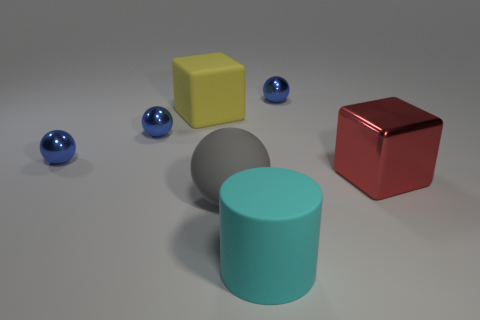Subtract all tiny blue shiny spheres. How many spheres are left? 1 Add 3 metal things. How many objects exist? 10 Subtract all cylinders. How many objects are left? 6 Subtract 2 balls. How many balls are left? 2 Subtract all red blocks. How many blocks are left? 1 Subtract 0 red cylinders. How many objects are left? 7 Subtract all cyan balls. Subtract all blue cubes. How many balls are left? 4 Subtract all blue cylinders. How many cyan blocks are left? 0 Subtract all large metallic things. Subtract all gray rubber balls. How many objects are left? 5 Add 2 big red shiny cubes. How many big red shiny cubes are left? 3 